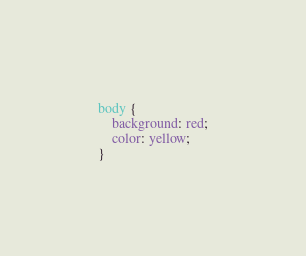Convert code to text. <code><loc_0><loc_0><loc_500><loc_500><_CSS_>body {
    background: red;
    color: yellow;
}</code> 